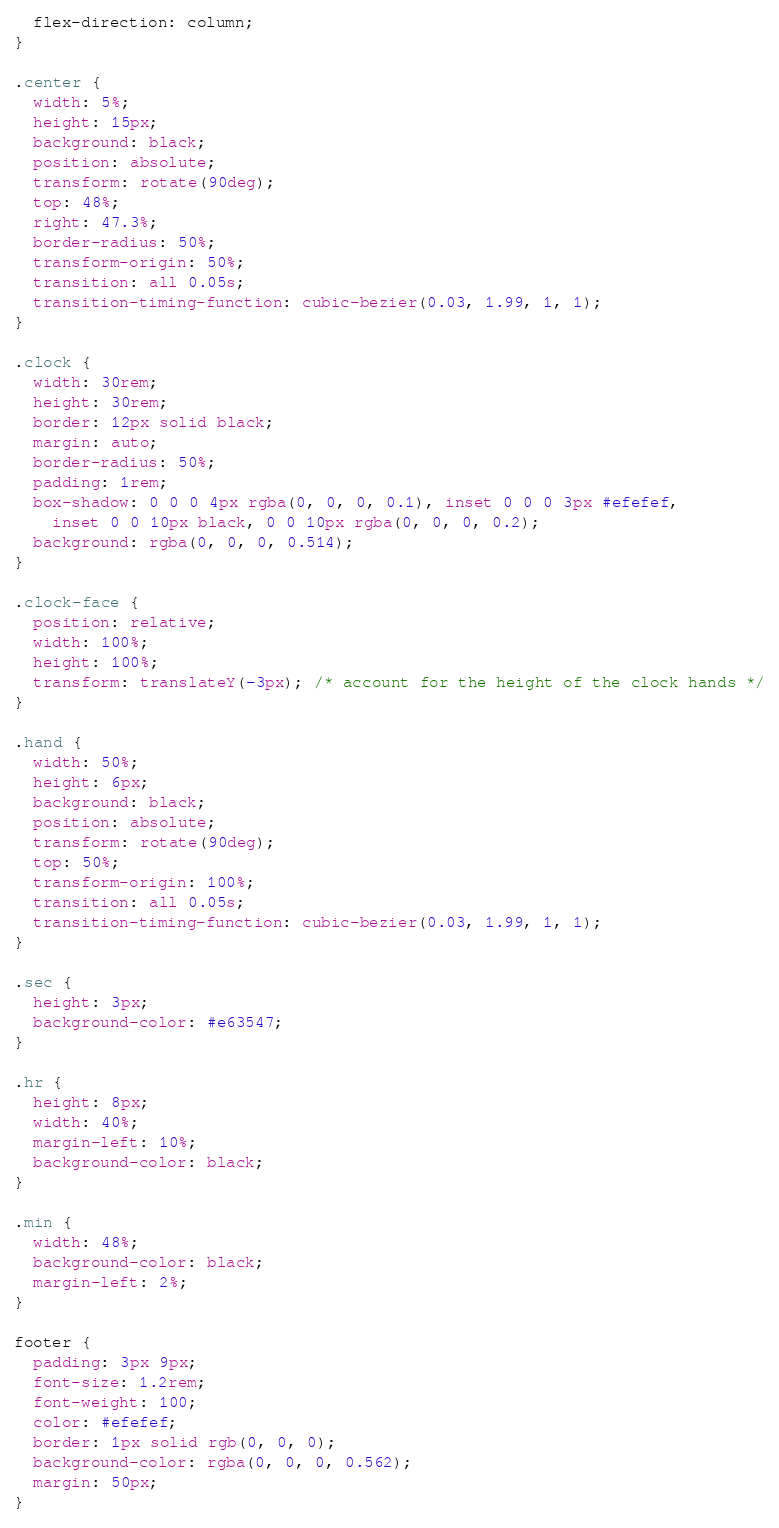<code> <loc_0><loc_0><loc_500><loc_500><_CSS_>  flex-direction: column;
}

.center {
  width: 5%;
  height: 15px;
  background: black;
  position: absolute;
  transform: rotate(90deg);
  top: 48%;
  right: 47.3%;
  border-radius: 50%;
  transform-origin: 50%;
  transition: all 0.05s;
  transition-timing-function: cubic-bezier(0.03, 1.99, 1, 1);
}

.clock {
  width: 30rem;
  height: 30rem;
  border: 12px solid black;
  margin: auto;
  border-radius: 50%;
  padding: 1rem;
  box-shadow: 0 0 0 4px rgba(0, 0, 0, 0.1), inset 0 0 0 3px #efefef,
    inset 0 0 10px black, 0 0 10px rgba(0, 0, 0, 0.2);
  background: rgba(0, 0, 0, 0.514);
}

.clock-face {
  position: relative;
  width: 100%;
  height: 100%;
  transform: translateY(-3px); /* account for the height of the clock hands */
}

.hand {
  width: 50%;
  height: 6px;
  background: black;
  position: absolute;
  transform: rotate(90deg);
  top: 50%;
  transform-origin: 100%;
  transition: all 0.05s;
  transition-timing-function: cubic-bezier(0.03, 1.99, 1, 1);
}

.sec {
  height: 3px;
  background-color: #e63547;
}

.hr {
  height: 8px;
  width: 40%;
  margin-left: 10%;
  background-color: black;
}

.min {
  width: 48%;
  background-color: black;
  margin-left: 2%;
}

footer {
  padding: 3px 9px;
  font-size: 1.2rem;
  font-weight: 100;
  color: #efefef;
  border: 1px solid rgb(0, 0, 0);
  background-color: rgba(0, 0, 0, 0.562);
  margin: 50px;
}
</code> 